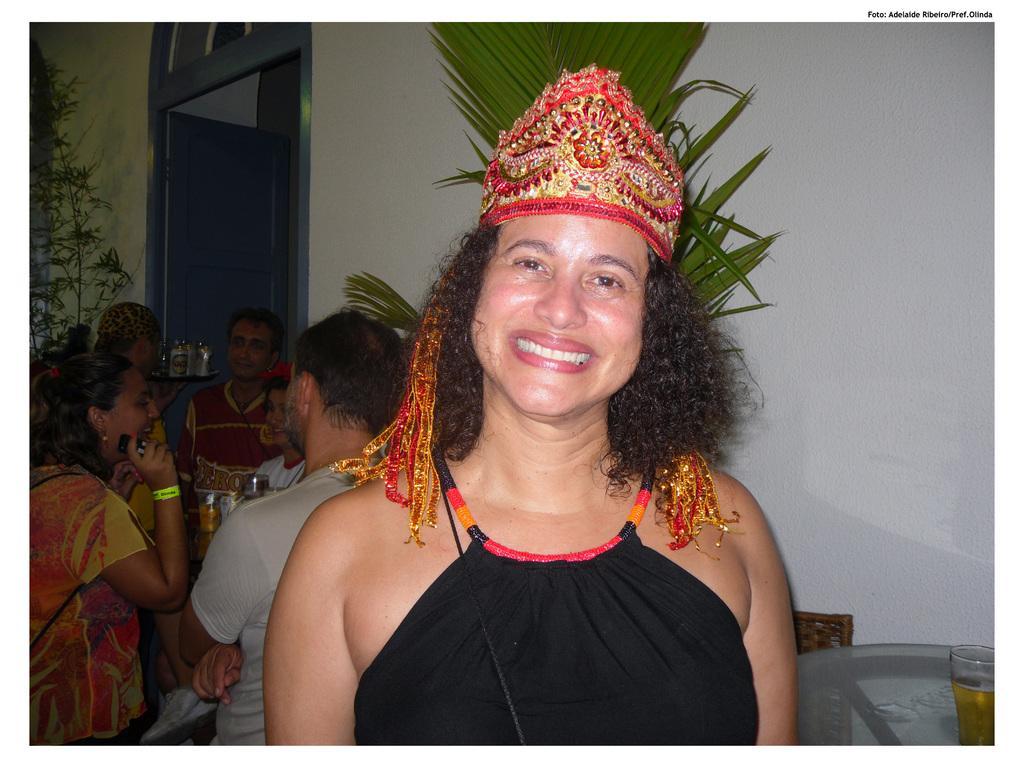In one or two sentences, can you explain what this image depicts? In this image there is a person with crown, there are few people, few plants, a door, a glass with some drink on the table and a wall. 